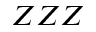Convert formula to latex. <formula><loc_0><loc_0><loc_500><loc_500>Z Z Z</formula> 